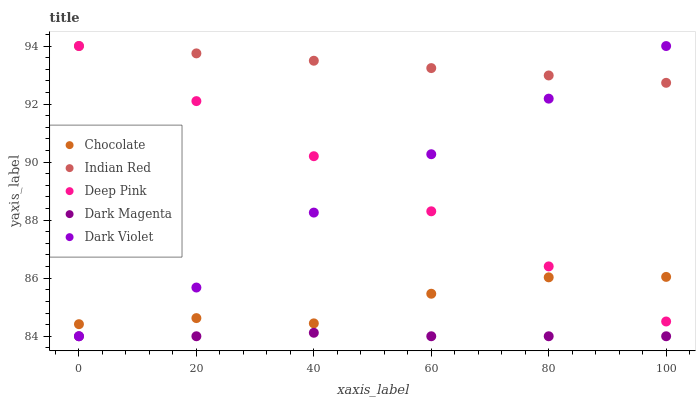Does Dark Magenta have the minimum area under the curve?
Answer yes or no. Yes. Does Indian Red have the maximum area under the curve?
Answer yes or no. Yes. Does Deep Pink have the minimum area under the curve?
Answer yes or no. No. Does Deep Pink have the maximum area under the curve?
Answer yes or no. No. Is Deep Pink the smoothest?
Answer yes or no. Yes. Is Chocolate the roughest?
Answer yes or no. Yes. Is Dark Magenta the smoothest?
Answer yes or no. No. Is Dark Magenta the roughest?
Answer yes or no. No. Does Dark Violet have the lowest value?
Answer yes or no. Yes. Does Deep Pink have the lowest value?
Answer yes or no. No. Does Indian Red have the highest value?
Answer yes or no. Yes. Does Dark Magenta have the highest value?
Answer yes or no. No. Is Chocolate less than Indian Red?
Answer yes or no. Yes. Is Chocolate greater than Dark Magenta?
Answer yes or no. Yes. Does Dark Violet intersect Indian Red?
Answer yes or no. Yes. Is Dark Violet less than Indian Red?
Answer yes or no. No. Is Dark Violet greater than Indian Red?
Answer yes or no. No. Does Chocolate intersect Indian Red?
Answer yes or no. No. 